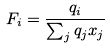<formula> <loc_0><loc_0><loc_500><loc_500>F _ { i } = \frac { q _ { i } } { \sum _ { j } q _ { j } x _ { j } }</formula> 